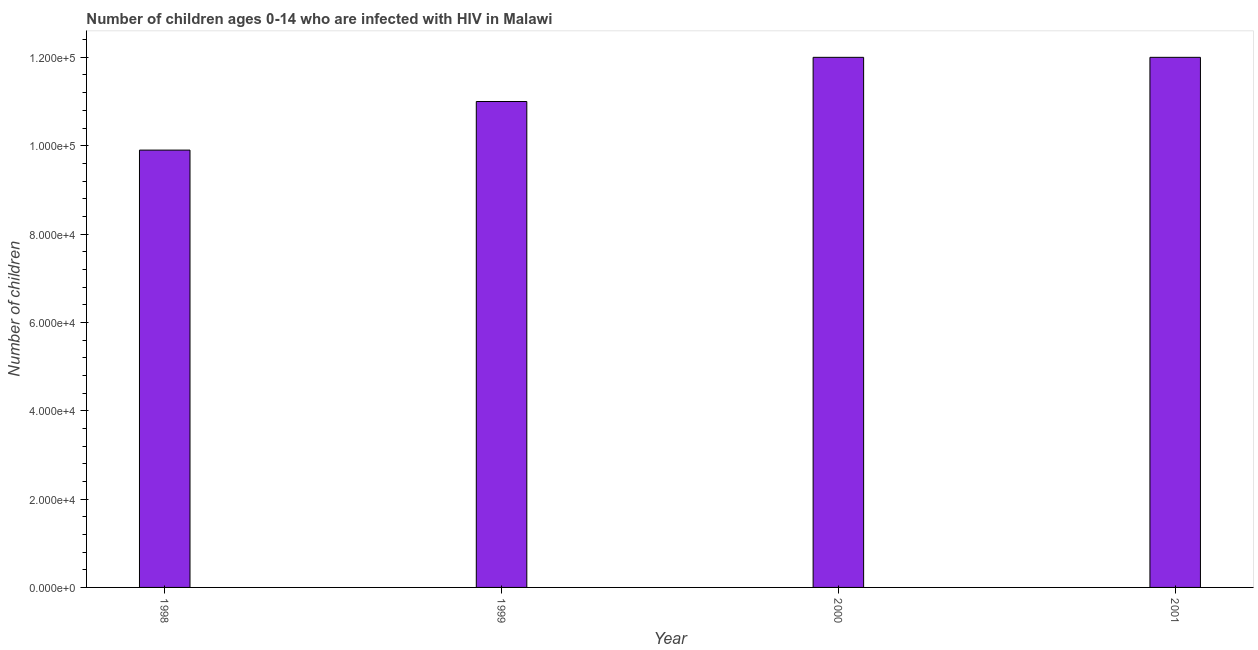What is the title of the graph?
Make the answer very short. Number of children ages 0-14 who are infected with HIV in Malawi. What is the label or title of the X-axis?
Offer a very short reply. Year. What is the label or title of the Y-axis?
Offer a terse response. Number of children. What is the number of children living with hiv in 2001?
Ensure brevity in your answer.  1.20e+05. Across all years, what is the maximum number of children living with hiv?
Ensure brevity in your answer.  1.20e+05. Across all years, what is the minimum number of children living with hiv?
Provide a succinct answer. 9.90e+04. In which year was the number of children living with hiv maximum?
Ensure brevity in your answer.  2000. What is the sum of the number of children living with hiv?
Ensure brevity in your answer.  4.49e+05. What is the average number of children living with hiv per year?
Ensure brevity in your answer.  1.12e+05. What is the median number of children living with hiv?
Your answer should be compact. 1.15e+05. In how many years, is the number of children living with hiv greater than 44000 ?
Offer a very short reply. 4. Do a majority of the years between 1998 and 2001 (inclusive) have number of children living with hiv greater than 104000 ?
Offer a very short reply. Yes. What is the ratio of the number of children living with hiv in 2000 to that in 2001?
Your response must be concise. 1. Is the number of children living with hiv in 1998 less than that in 1999?
Provide a short and direct response. Yes. Is the difference between the number of children living with hiv in 1998 and 1999 greater than the difference between any two years?
Provide a succinct answer. No. Is the sum of the number of children living with hiv in 1998 and 2001 greater than the maximum number of children living with hiv across all years?
Ensure brevity in your answer.  Yes. What is the difference between the highest and the lowest number of children living with hiv?
Your answer should be very brief. 2.10e+04. Are all the bars in the graph horizontal?
Your answer should be compact. No. What is the difference between two consecutive major ticks on the Y-axis?
Ensure brevity in your answer.  2.00e+04. What is the Number of children in 1998?
Offer a very short reply. 9.90e+04. What is the Number of children in 2000?
Provide a succinct answer. 1.20e+05. What is the difference between the Number of children in 1998 and 1999?
Your answer should be compact. -1.10e+04. What is the difference between the Number of children in 1998 and 2000?
Ensure brevity in your answer.  -2.10e+04. What is the difference between the Number of children in 1998 and 2001?
Provide a short and direct response. -2.10e+04. What is the difference between the Number of children in 1999 and 2000?
Provide a succinct answer. -10000. What is the difference between the Number of children in 1999 and 2001?
Offer a very short reply. -10000. What is the difference between the Number of children in 2000 and 2001?
Make the answer very short. 0. What is the ratio of the Number of children in 1998 to that in 2000?
Your response must be concise. 0.82. What is the ratio of the Number of children in 1998 to that in 2001?
Your answer should be compact. 0.82. What is the ratio of the Number of children in 1999 to that in 2000?
Make the answer very short. 0.92. What is the ratio of the Number of children in 1999 to that in 2001?
Provide a short and direct response. 0.92. 